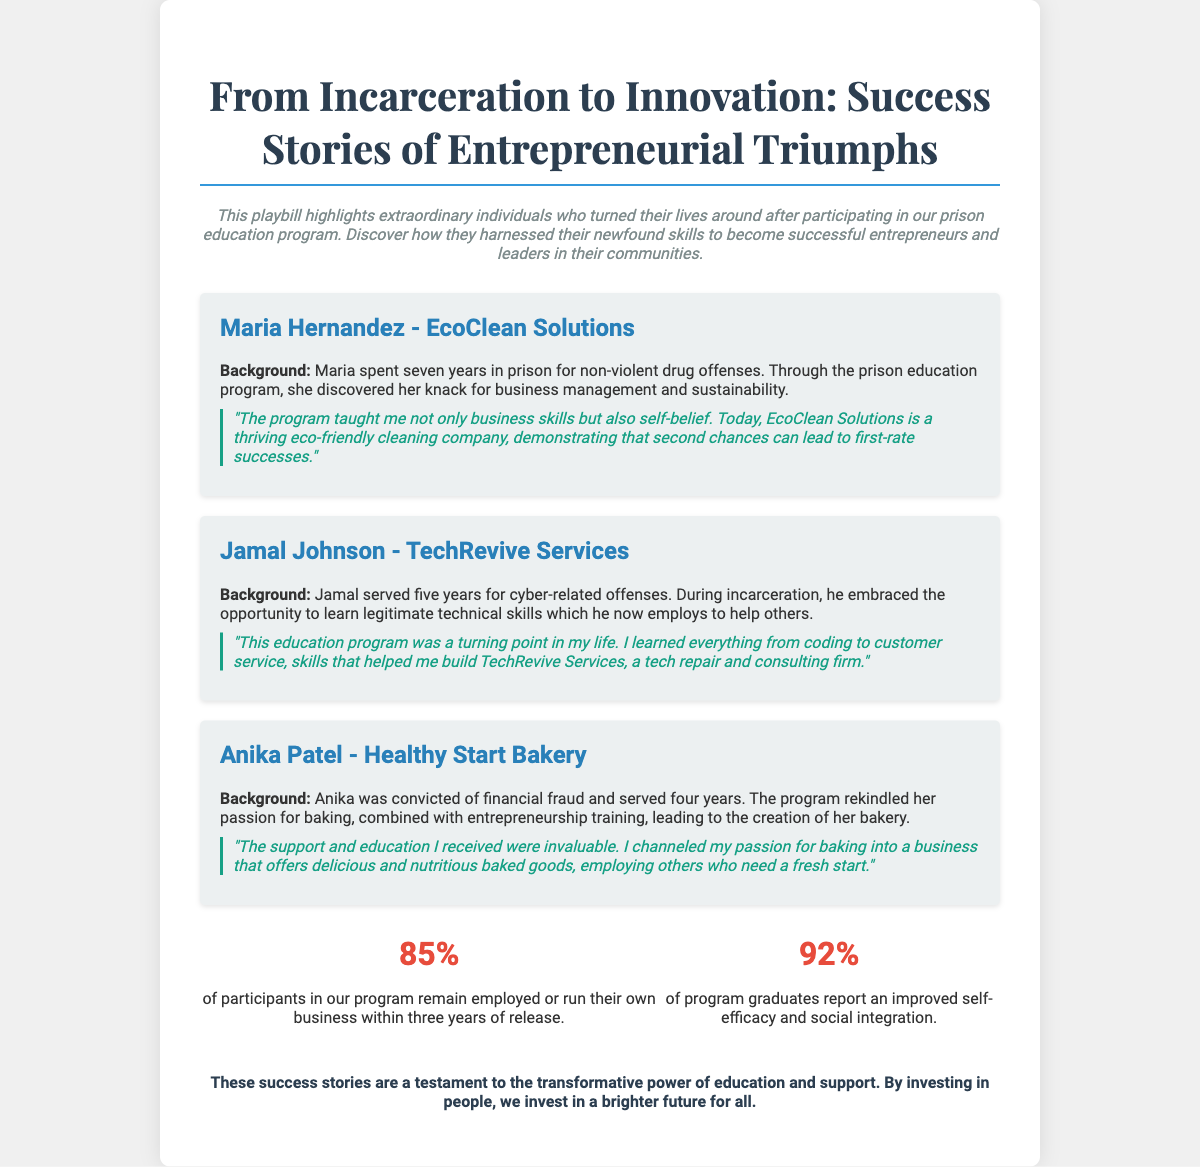What is the title of the showcase? The title provides insight into the theme of the document, highlighting the transformation from incarceration to entrepreneurship.
Answer: From Incarceration to Innovation: Success Stories How many years did Maria Hernandez spend in prison? The document states the duration of Maria's incarceration, which is crucial for understanding her background.
Answer: seven years What is the name of Jamal Johnson's business? This question seeks to identify the entrepreneurial venture established by Jamal, which is a key focus of the showcase.
Answer: TechRevive Services What percentage of participants remain employed or run their own business within three years of release? This statistic highlights the program's success rate, demonstrating its effectiveness.
Answer: 85% What did Anika Patel's bakery specialize in? Understanding the specific focus of Anika's business provides insights into her entrepreneurial journey.
Answer: nutritious baked goods Which business did Maria Hernandez establish? This question directly pertains to the business venture that resulted from Maria's educational experience.
Answer: EcoClean Solutions What aspect of the program did Jamal Johnson appreciate the most? This question evaluates Jamal’s reflections on the program's impact on his life and career.
Answer: education program What color is primarily used for headings in the document? Identifying colors used in headings gives insight into the visual design elements of the document.
Answer: blue How many profiles are featured in the showcase? This question seeks to quantify the number of success stories shared within the document, key for understanding its breadth.
Answer: three profiles 